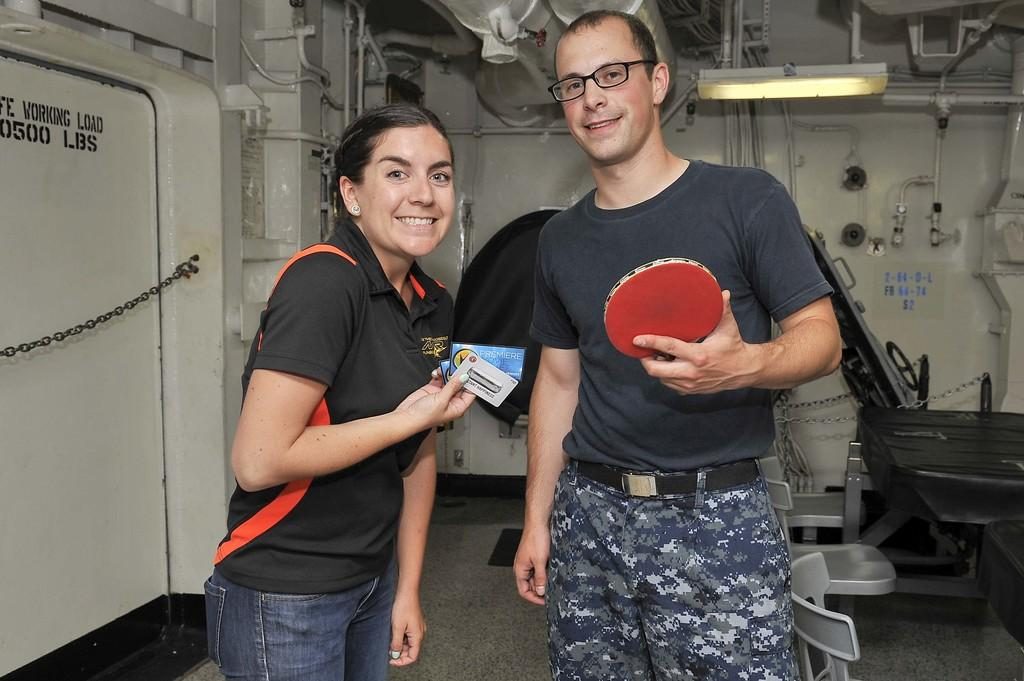How many people are present in the image? There are two people in the image, a woman and a man. What is the man holding in his hand? The man is holding a table tennis paddle or racket in his hand. What type of banana is the man eating in the image? There is no banana present in the image; the man is holding a table tennis paddle or racket. What is the profit margin of the table tennis paddle or racket in the image? The image does not provide information about the profit margin of the table tennis paddle or racket, as it is not a commercial context. 